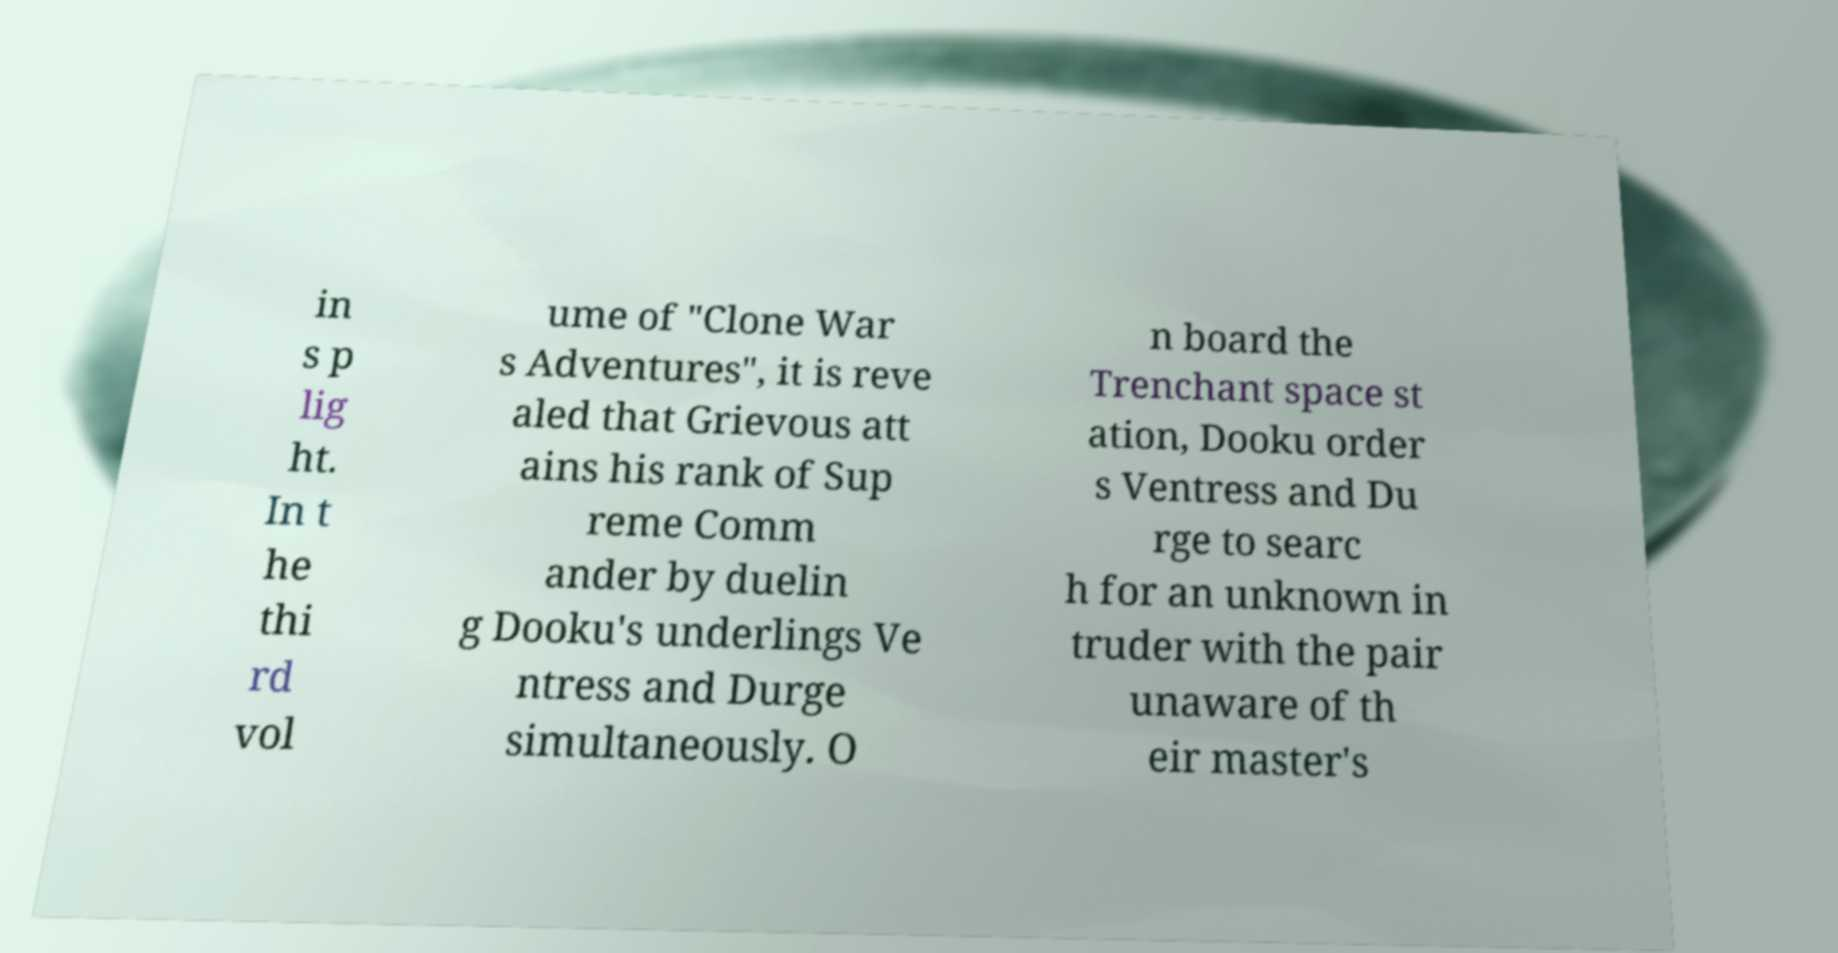Could you extract and type out the text from this image? in s p lig ht. In t he thi rd vol ume of "Clone War s Adventures", it is reve aled that Grievous att ains his rank of Sup reme Comm ander by duelin g Dooku's underlings Ve ntress and Durge simultaneously. O n board the Trenchant space st ation, Dooku order s Ventress and Du rge to searc h for an unknown in truder with the pair unaware of th eir master's 